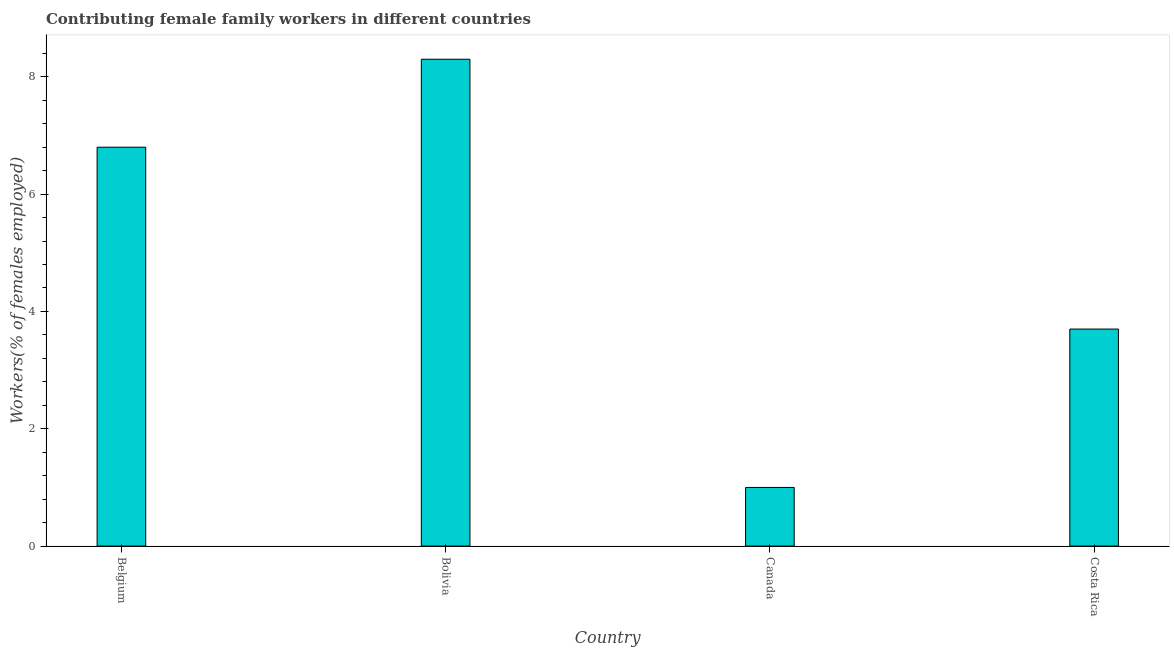Does the graph contain any zero values?
Offer a terse response. No. Does the graph contain grids?
Offer a very short reply. No. What is the title of the graph?
Give a very brief answer. Contributing female family workers in different countries. What is the label or title of the X-axis?
Your answer should be compact. Country. What is the label or title of the Y-axis?
Your answer should be compact. Workers(% of females employed). What is the contributing female family workers in Bolivia?
Keep it short and to the point. 8.3. Across all countries, what is the maximum contributing female family workers?
Keep it short and to the point. 8.3. Across all countries, what is the minimum contributing female family workers?
Your answer should be very brief. 1. In which country was the contributing female family workers maximum?
Your response must be concise. Bolivia. In which country was the contributing female family workers minimum?
Ensure brevity in your answer.  Canada. What is the sum of the contributing female family workers?
Your answer should be very brief. 19.8. What is the average contributing female family workers per country?
Offer a very short reply. 4.95. What is the median contributing female family workers?
Give a very brief answer. 5.25. What is the ratio of the contributing female family workers in Belgium to that in Costa Rica?
Your answer should be very brief. 1.84. Is the sum of the contributing female family workers in Belgium and Canada greater than the maximum contributing female family workers across all countries?
Make the answer very short. No. What is the difference between the highest and the lowest contributing female family workers?
Your answer should be compact. 7.3. How many bars are there?
Ensure brevity in your answer.  4. What is the difference between two consecutive major ticks on the Y-axis?
Provide a short and direct response. 2. What is the Workers(% of females employed) of Belgium?
Give a very brief answer. 6.8. What is the Workers(% of females employed) of Bolivia?
Your response must be concise. 8.3. What is the Workers(% of females employed) of Costa Rica?
Keep it short and to the point. 3.7. What is the difference between the Workers(% of females employed) in Belgium and Costa Rica?
Your answer should be compact. 3.1. What is the difference between the Workers(% of females employed) in Bolivia and Canada?
Keep it short and to the point. 7.3. What is the difference between the Workers(% of females employed) in Bolivia and Costa Rica?
Provide a succinct answer. 4.6. What is the difference between the Workers(% of females employed) in Canada and Costa Rica?
Make the answer very short. -2.7. What is the ratio of the Workers(% of females employed) in Belgium to that in Bolivia?
Your answer should be compact. 0.82. What is the ratio of the Workers(% of females employed) in Belgium to that in Costa Rica?
Ensure brevity in your answer.  1.84. What is the ratio of the Workers(% of females employed) in Bolivia to that in Costa Rica?
Give a very brief answer. 2.24. What is the ratio of the Workers(% of females employed) in Canada to that in Costa Rica?
Your answer should be compact. 0.27. 